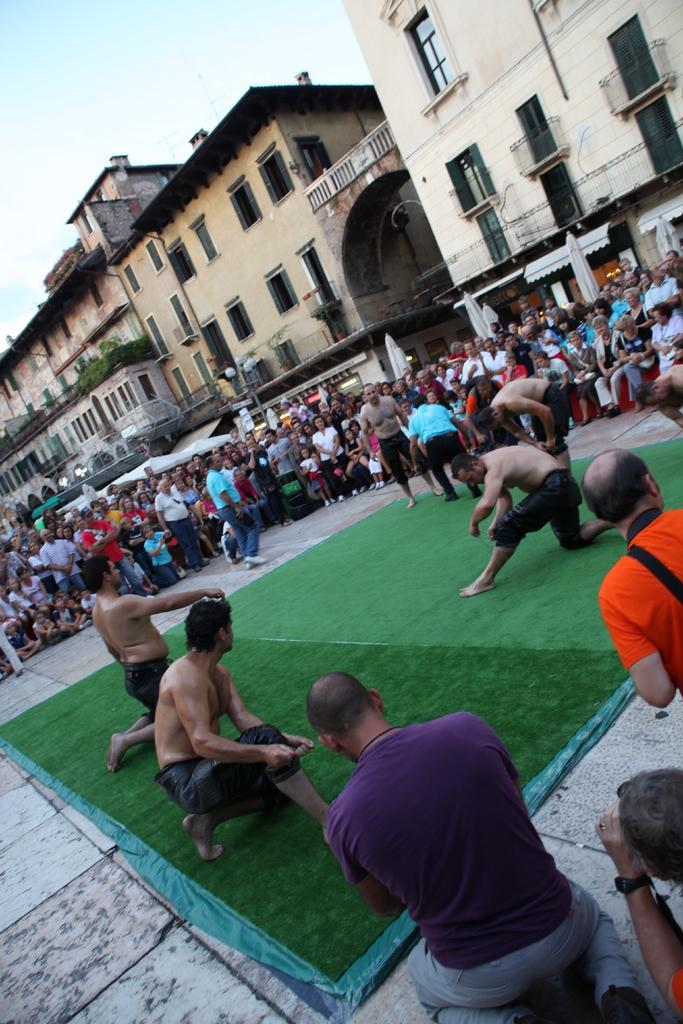What are the people in the image doing? There are persons on the ground and standing at the side in the image. What can be seen on the right side of the image? There are buildings and a street light at the right side of the image. What is visible at the top of the image? The sky is visible at the top of the image. Can you see the person raking leaves in the image? There is no person raking leaves in the image. What type of light is the person holding in the image? There is no person holding a light in the image; there is a street light at the right side of the image. 